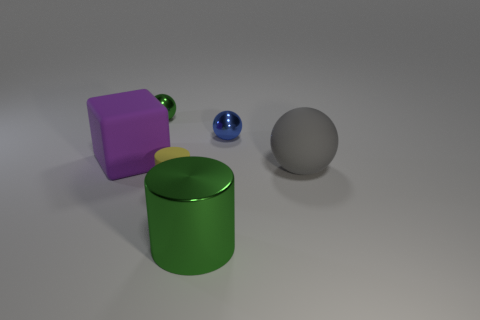Add 2 large purple matte things. How many objects exist? 8 Subtract all blocks. How many objects are left? 5 Subtract 0 purple cylinders. How many objects are left? 6 Subtract all purple matte blocks. Subtract all big matte blocks. How many objects are left? 4 Add 2 green metal cylinders. How many green metal cylinders are left? 3 Add 5 small blue spheres. How many small blue spheres exist? 6 